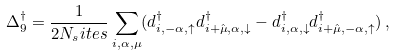Convert formula to latex. <formula><loc_0><loc_0><loc_500><loc_500>\Delta _ { 9 } ^ { \dagger } = \frac { 1 } { 2 N _ { s } i t e s } \sum _ { { i } , \alpha , \mu } ( d ^ { \dagger } _ { { i } , - \alpha , \uparrow } d ^ { \dagger } _ { { i } + \hat { \mu } , \alpha , \downarrow } - d ^ { \dagger } _ { { i } , \alpha , \downarrow } d ^ { \dagger } _ { { i } + \hat { \mu } , - \alpha , \uparrow } ) \, ,</formula> 